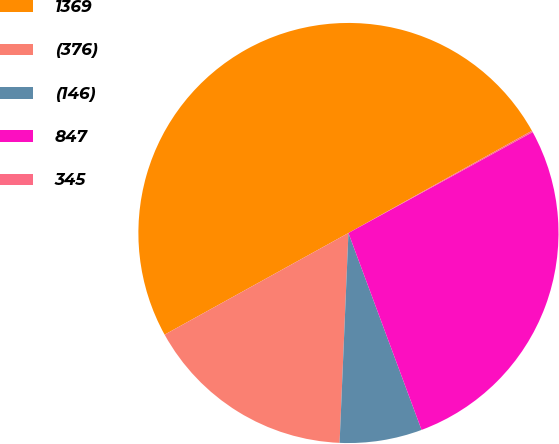Convert chart. <chart><loc_0><loc_0><loc_500><loc_500><pie_chart><fcel>1369<fcel>(376)<fcel>(146)<fcel>847<fcel>345<nl><fcel>49.95%<fcel>16.29%<fcel>6.33%<fcel>27.32%<fcel>0.11%<nl></chart> 